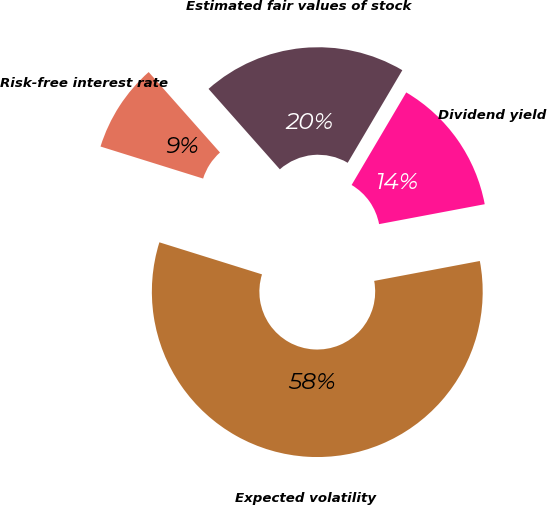<chart> <loc_0><loc_0><loc_500><loc_500><pie_chart><fcel>Estimated fair values of stock<fcel>Risk-free interest rate<fcel>Expected volatility<fcel>Dividend yield<nl><fcel>20.03%<fcel>8.64%<fcel>57.79%<fcel>13.55%<nl></chart> 